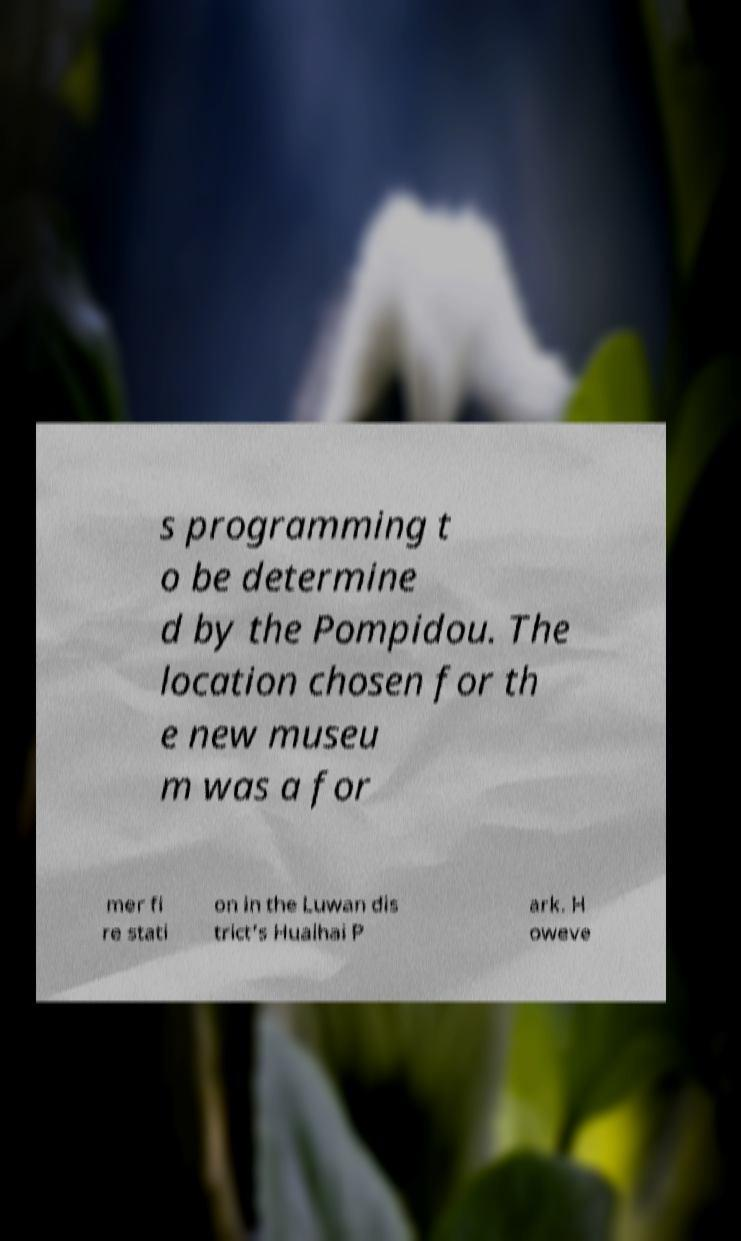For documentation purposes, I need the text within this image transcribed. Could you provide that? s programming t o be determine d by the Pompidou. The location chosen for th e new museu m was a for mer fi re stati on in the Luwan dis trict's Huaihai P ark. H oweve 